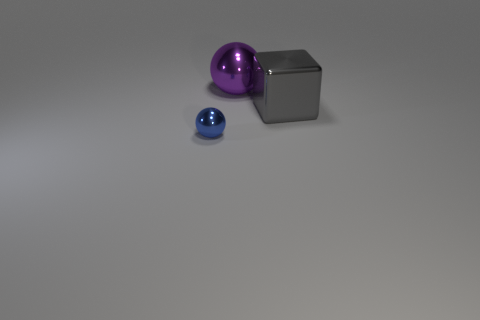Add 3 tiny cyan rubber cylinders. How many tiny cyan rubber cylinders exist? 3 Add 1 cubes. How many objects exist? 4 Subtract 0 purple cylinders. How many objects are left? 3 Subtract all blocks. How many objects are left? 2 Subtract 1 spheres. How many spheres are left? 1 Subtract all red spheres. Subtract all yellow cylinders. How many spheres are left? 2 Subtract all blue spheres. How many blue cubes are left? 0 Subtract all large purple spheres. Subtract all gray metallic objects. How many objects are left? 1 Add 1 big gray things. How many big gray things are left? 2 